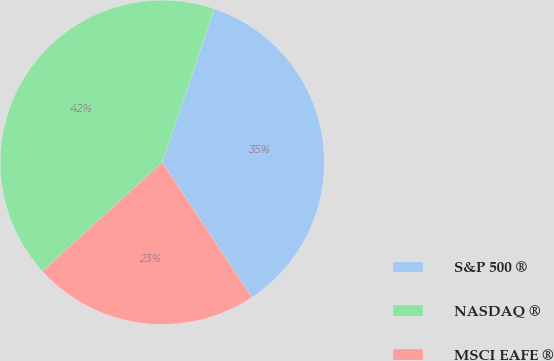Convert chart to OTSL. <chart><loc_0><loc_0><loc_500><loc_500><pie_chart><fcel>S&P 500 ®<fcel>NASDAQ ®<fcel>MSCI EAFE ®<nl><fcel>35.48%<fcel>41.94%<fcel>22.58%<nl></chart> 